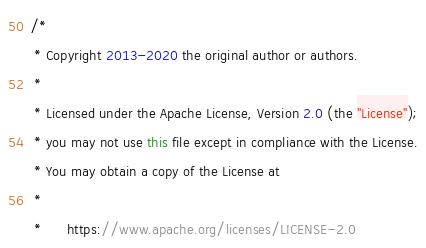Convert code to text. <code><loc_0><loc_0><loc_500><loc_500><_Java_>/*
 * Copyright 2013-2020 the original author or authors.
 *
 * Licensed under the Apache License, Version 2.0 (the "License");
 * you may not use this file except in compliance with the License.
 * You may obtain a copy of the License at
 *
 *      https://www.apache.org/licenses/LICENSE-2.0</code> 